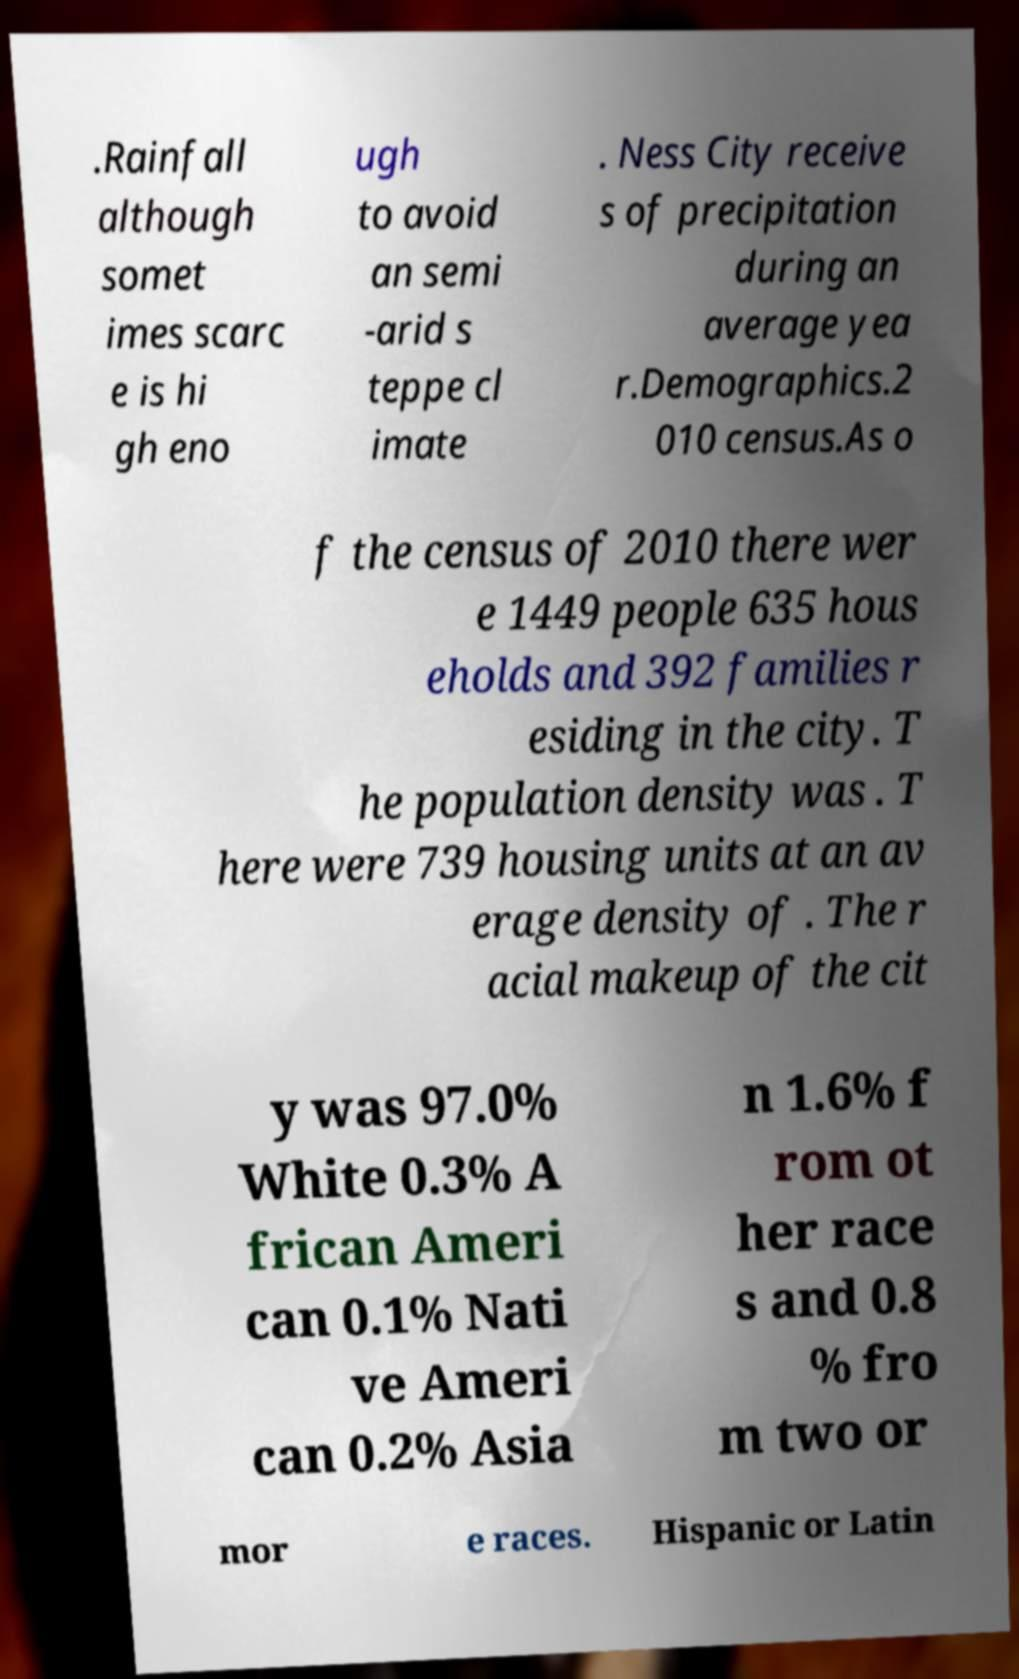Please read and relay the text visible in this image. What does it say? .Rainfall although somet imes scarc e is hi gh eno ugh to avoid an semi -arid s teppe cl imate . Ness City receive s of precipitation during an average yea r.Demographics.2 010 census.As o f the census of 2010 there wer e 1449 people 635 hous eholds and 392 families r esiding in the city. T he population density was . T here were 739 housing units at an av erage density of . The r acial makeup of the cit y was 97.0% White 0.3% A frican Ameri can 0.1% Nati ve Ameri can 0.2% Asia n 1.6% f rom ot her race s and 0.8 % fro m two or mor e races. Hispanic or Latin 